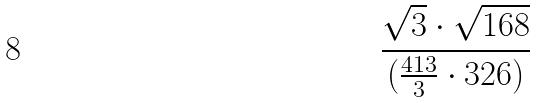<formula> <loc_0><loc_0><loc_500><loc_500>\frac { \sqrt { 3 } \cdot \sqrt { 1 6 8 } } { ( \frac { 4 1 3 } { 3 } \cdot 3 2 6 ) }</formula> 